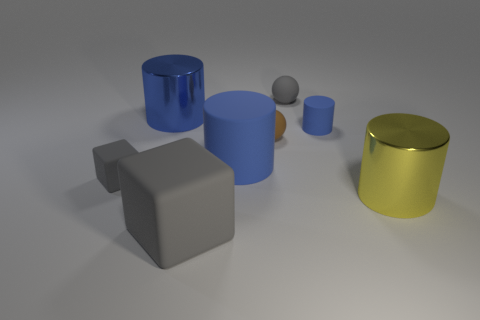How many blue cylinders must be subtracted to get 1 blue cylinders? 2 Add 1 gray rubber objects. How many objects exist? 9 Subtract all big cylinders. How many cylinders are left? 1 Subtract all balls. How many objects are left? 6 Subtract 1 cylinders. How many cylinders are left? 3 Subtract all yellow cylinders. How many cylinders are left? 3 Subtract all purple cylinders. Subtract all brown balls. How many cylinders are left? 4 Subtract all purple cylinders. How many gray balls are left? 1 Subtract all small objects. Subtract all yellow cylinders. How many objects are left? 3 Add 4 brown matte objects. How many brown matte objects are left? 5 